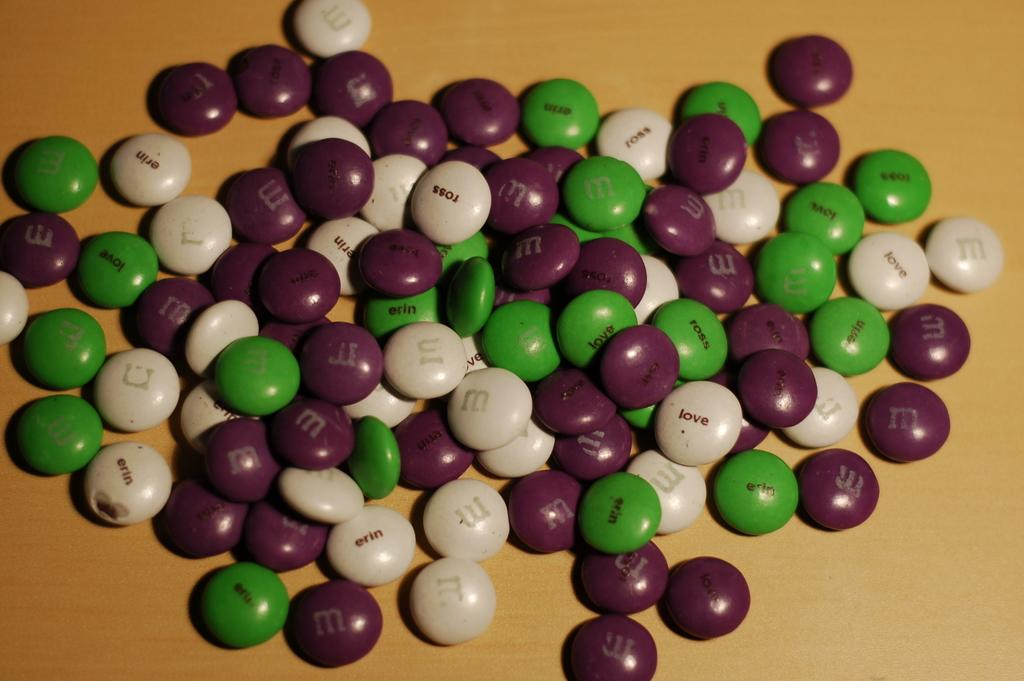What type of candy is present in the image? There are M&Ms in the image. What colors are the M&Ms in the image? The M&Ms are green, cream, and brown in color. What is the color of the surface in the image? The surface in the image is brown and cream colored. Can you see a crow interacting with the farmer and giraffe in the image? There is no crow, farmer, or giraffe present in the image. 